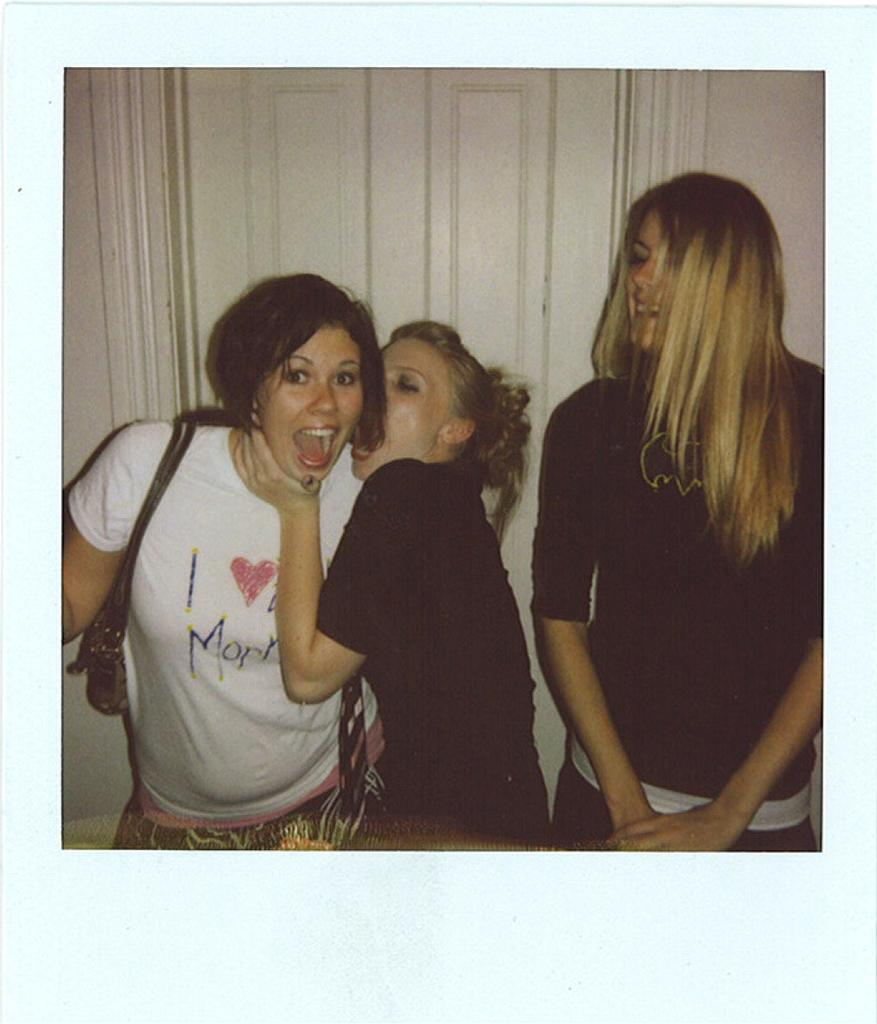How many women are in the image? There are three women in the image. What are the women standing near? The women are standing near a wooden white door. What color is the wall in the image? There is a white wall in the image. Can you describe the accessories worn by one of the women? One woman is wearing a handbag. What type of interest can be seen growing on the bed in the image? There is no bed present in the image, and therefore no interest can be observed. 